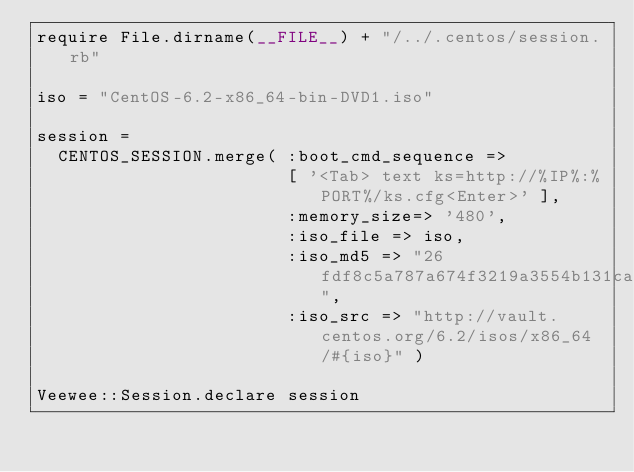<code> <loc_0><loc_0><loc_500><loc_500><_Ruby_>require File.dirname(__FILE__) + "/../.centos/session.rb"

iso = "CentOS-6.2-x86_64-bin-DVD1.iso"

session =
  CENTOS_SESSION.merge( :boot_cmd_sequence =>
                        [ '<Tab> text ks=http://%IP%:%PORT%/ks.cfg<Enter>' ],
                        :memory_size=> '480',
                        :iso_file => iso,
                        :iso_md5 => "26fdf8c5a787a674f3219a3554b131ca",
                        :iso_src => "http://vault.centos.org/6.2/isos/x86_64/#{iso}" )

Veewee::Session.declare session
</code> 